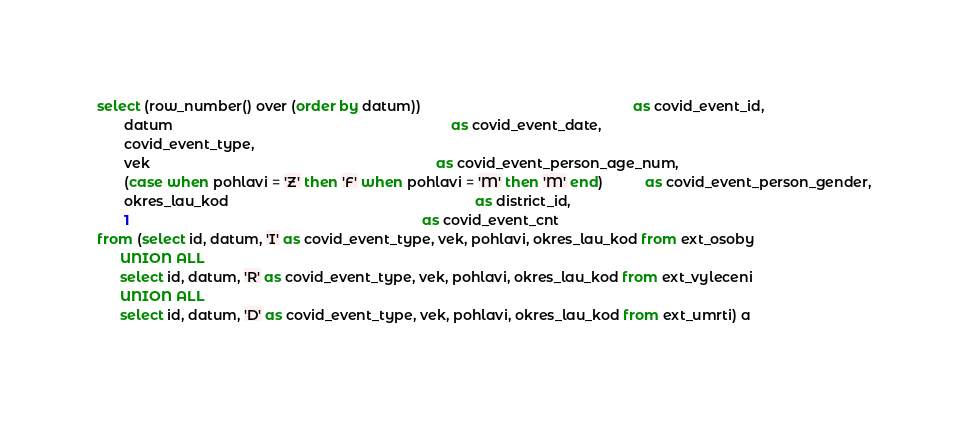Convert code to text. <code><loc_0><loc_0><loc_500><loc_500><_SQL_>select (row_number() over (order by datum))                                                       as covid_event_id,
       datum                                                                        as covid_event_date,
       covid_event_type,
       vek                                                                          as covid_event_person_age_num,
       (case when pohlavi = 'Z' then 'F' when pohlavi = 'M' then 'M' end)           as covid_event_person_gender,
       okres_lau_kod                                                                as district_id,
       1                                                                            as covid_event_cnt
from (select id, datum, 'I' as covid_event_type, vek, pohlavi, okres_lau_kod from ext_osoby
      UNION ALL
      select id, datum, 'R' as covid_event_type, vek, pohlavi, okres_lau_kod from ext_vyleceni
      UNION ALL
      select id, datum, 'D' as covid_event_type, vek, pohlavi, okres_lau_kod from ext_umrti) a
</code> 